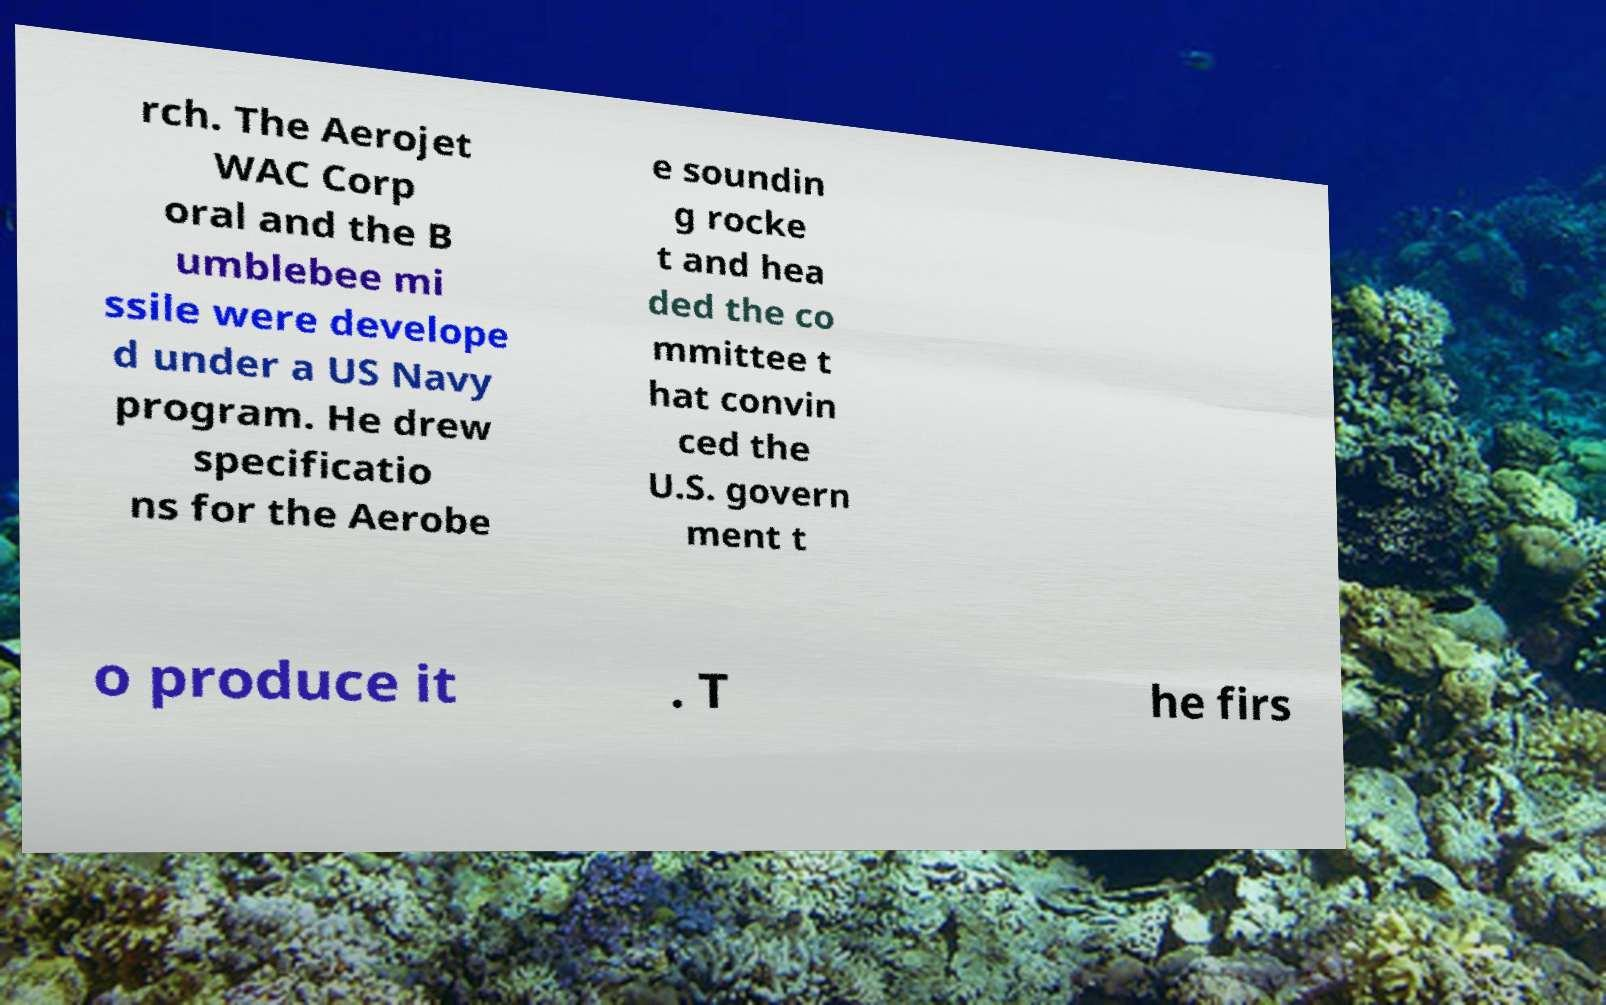Could you extract and type out the text from this image? rch. The Aerojet WAC Corp oral and the B umblebee mi ssile were develope d under a US Navy program. He drew specificatio ns for the Aerobe e soundin g rocke t and hea ded the co mmittee t hat convin ced the U.S. govern ment t o produce it . T he firs 